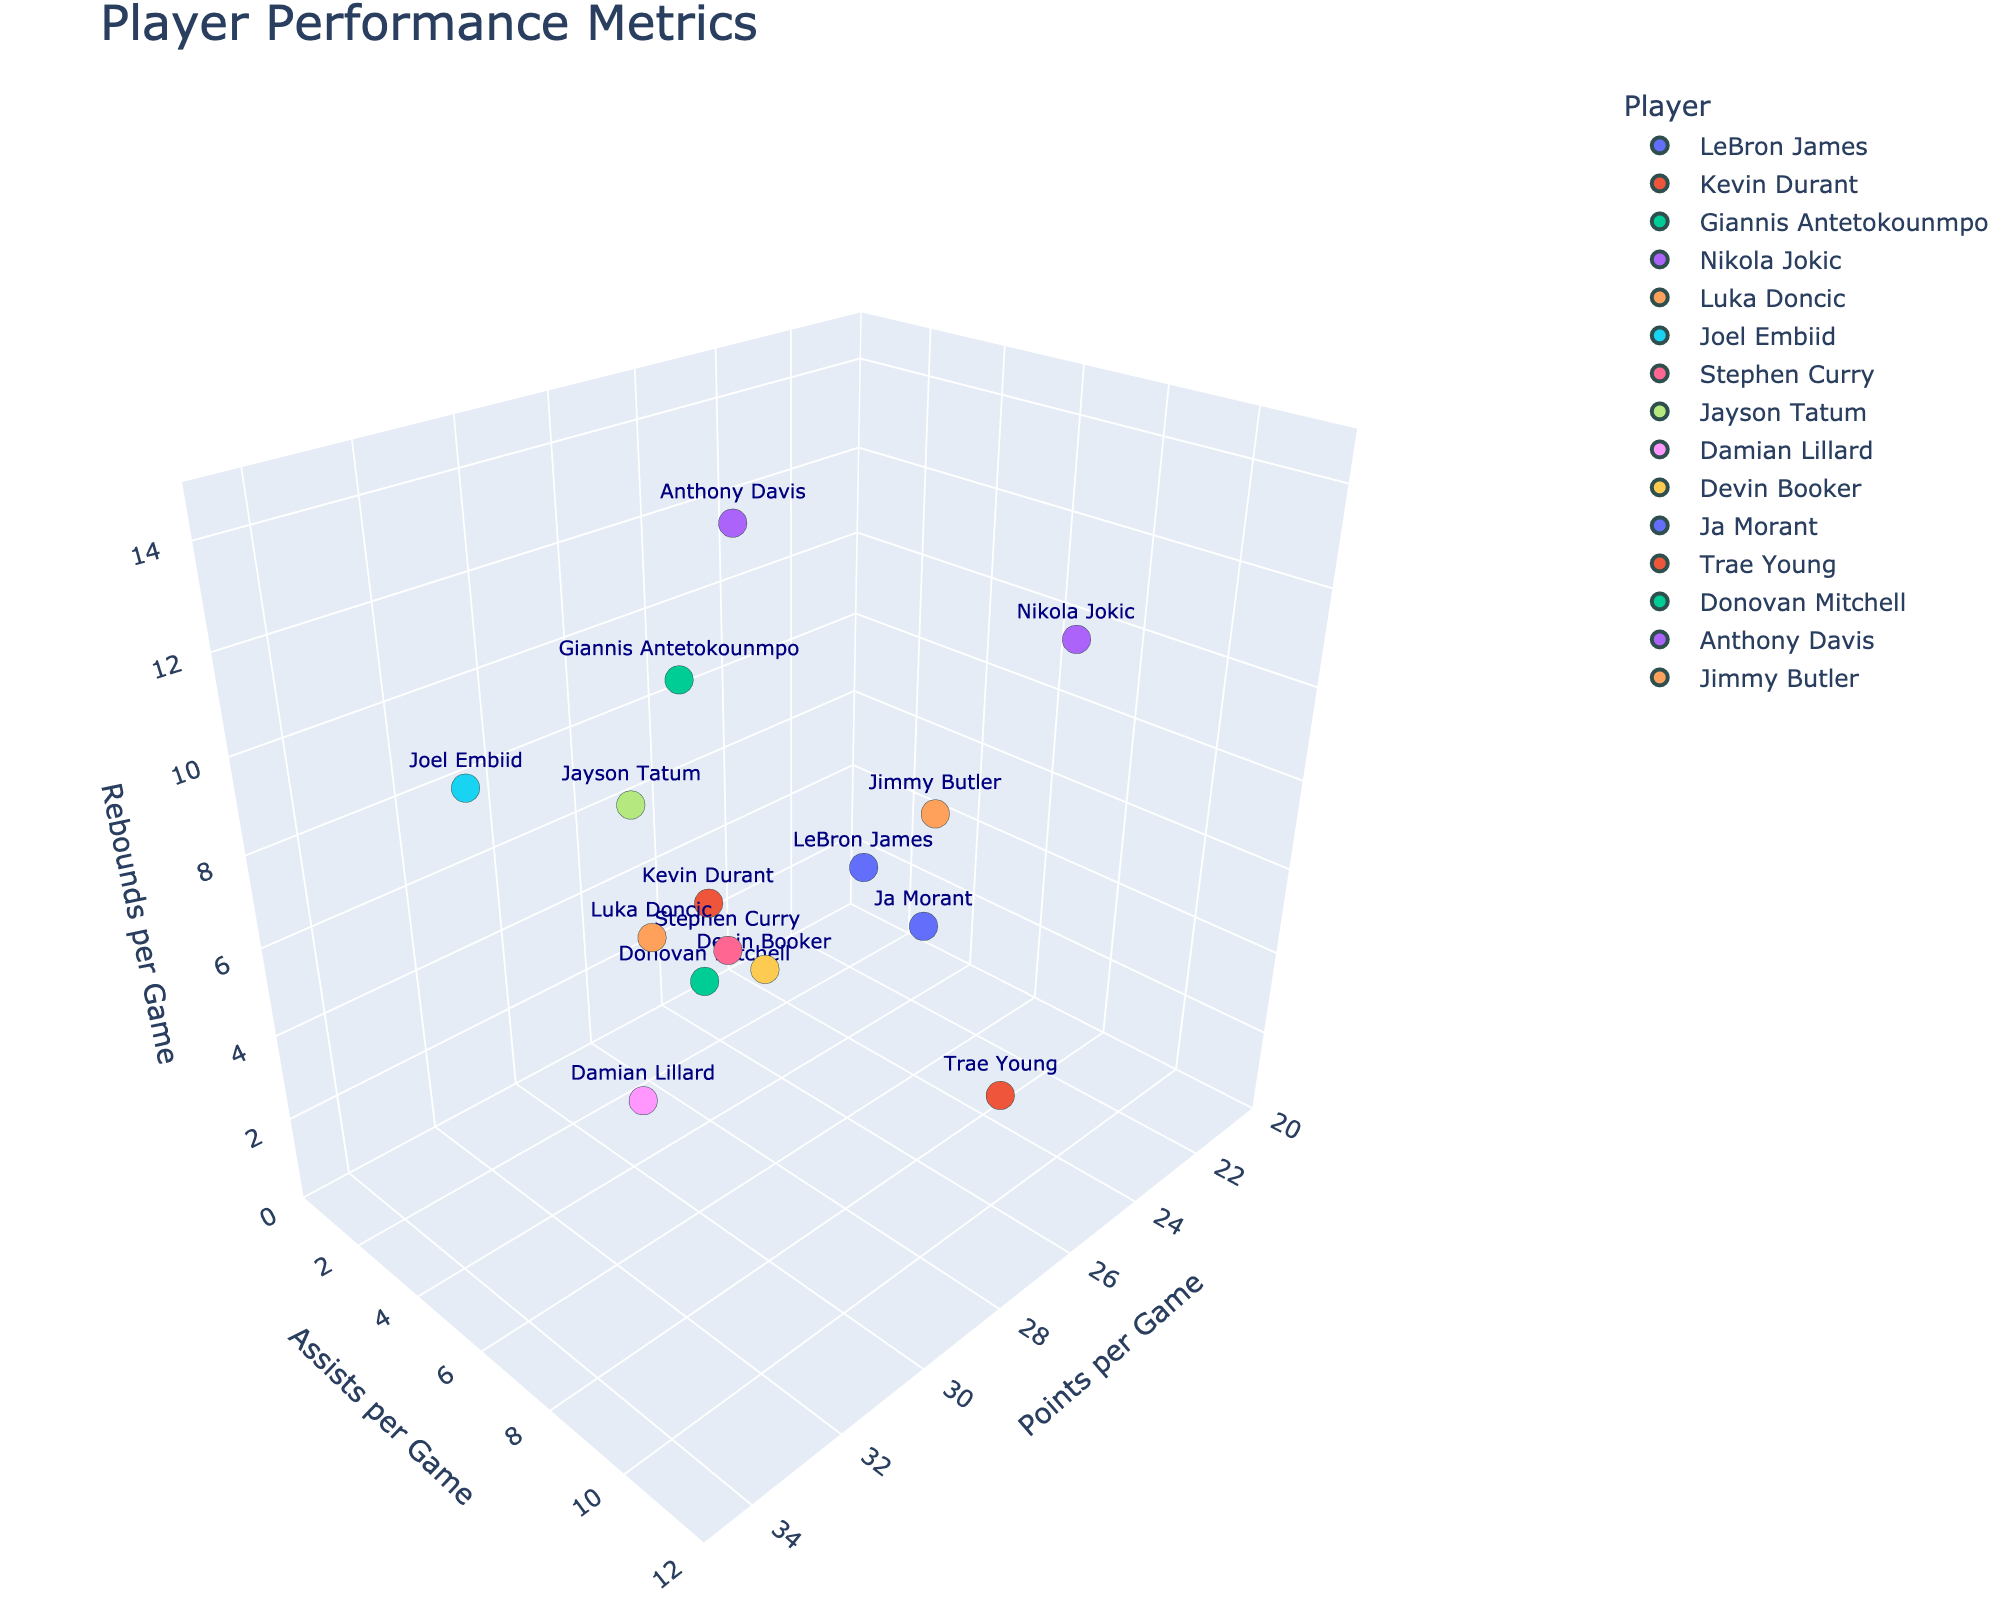What's the title of the plot? The title is located at the top of the figure and summarizes the content, which is about player performance metrics.
Answer: Player Performance Metrics How many players are represented in the plot? Each data point is labeled by a player's name, and we can count the total number of unique names present to determine the number of players.
Answer: 15 Which player scores the most points per game? By examining the x-axis (points per game), identify the player with the highest value. Joel Embiid has the highest score at 33.1 points per game.
Answer: Joel Embiid Who has more assists per game, Luka Doncic or Ja Morant? Look at the y-axis values for both players and compare their positions. Luka Doncic has 8.0 assists per game while Ja Morant has 8.1 assists per game.
Answer: Ja Morant Which player has the highest number of rebounds per game? Examine the z-axis (rebounds per game) to find the player with the highest value, which can be identified as the player with the highest vertical position in the plot. Anthony Davis has 12.5 rebounds per game.
Answer: Anthony Davis What is the combined total of points per game for Giannis Antetokounmpo, Nikola Jokic, and Jayson Tatum? Summing the points per game values from the plot for these three players: Giannis Antetokounmpo (29.9), Nikola Jokic (24.5), and Jayson Tatum (30.1). The total is 84.5 points per game.
Answer: 84.5 Which two players have the closest total rebounds per game? Compare the z-axis values for all players and identify those with the smallest difference in their rebounds per game values. LeBron James and Kevin Durant both have 7.4 rebounds per game, showing zero difference.
Answer: LeBron James and Kevin Durant In which range do most players' assists per game fall? Look at the y-axis (assists per game) and observe the frequency distribution of data points. A majority appear within the range of approximately 4.0 to 8.0 assists per game.
Answer: 4.0 to 8.0 Who has the highest combination of points and assists per game? For each player, sum their points per game and assists per game values, then identify the player with the highest sum. Luka Doncic has 32.4 points + 8.0 assists = 40.4 combined.
Answer: Luka Doncic Which player balances evenly between points, assists, and rebounds, meaning they do not have an extremely high or low value in any category? Look for players who have their markers placed roughly in the middle for all three axes (x, y, and z). LeBron James (27.2 points, 7.5 assists, 7.4 rebounds) and Jayson Tatum (30.1 points, 4.6 assists, 8.8 rebounds) have balanced metrics.
Answer: LeBron James or Jayson Tatum 